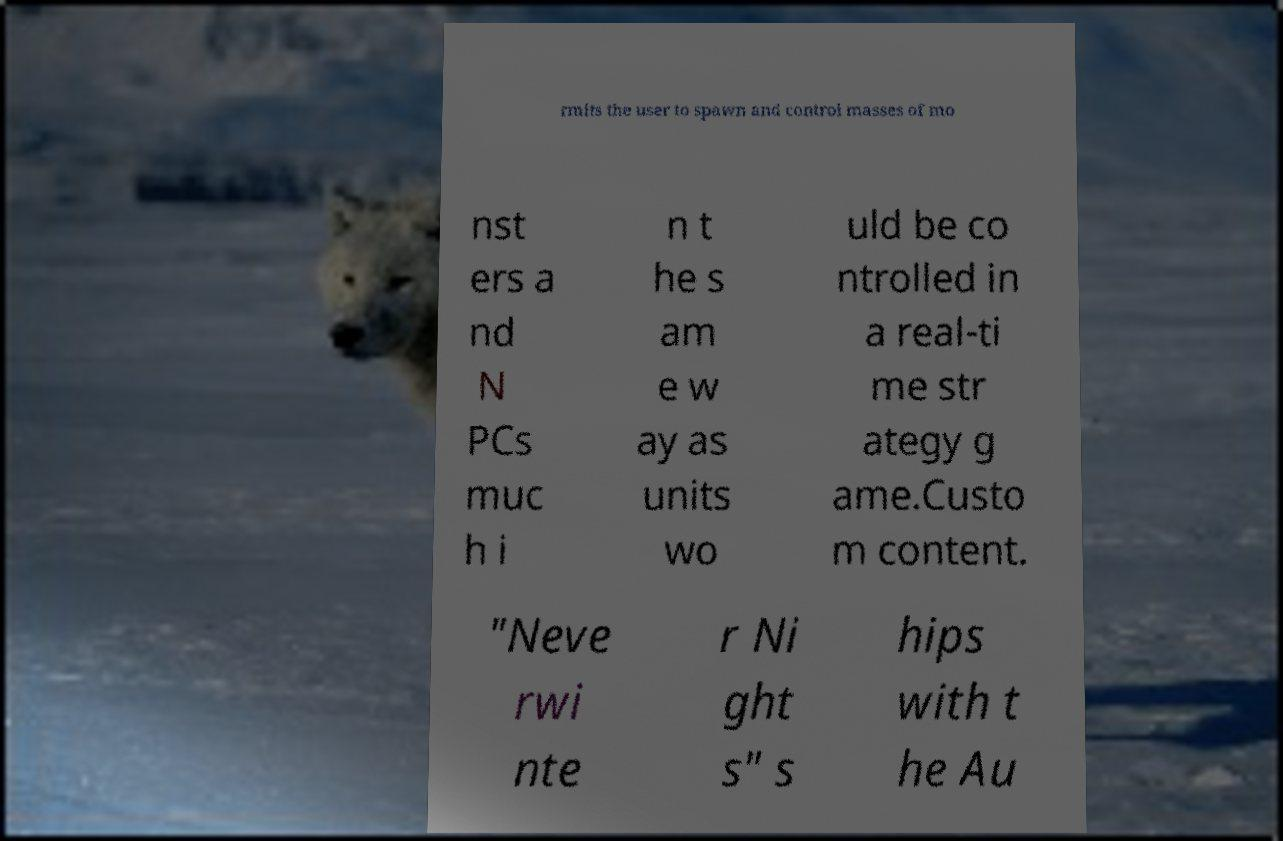What messages or text are displayed in this image? I need them in a readable, typed format. rmits the user to spawn and control masses of mo nst ers a nd N PCs muc h i n t he s am e w ay as units wo uld be co ntrolled in a real-ti me str ategy g ame.Custo m content. "Neve rwi nte r Ni ght s" s hips with t he Au 